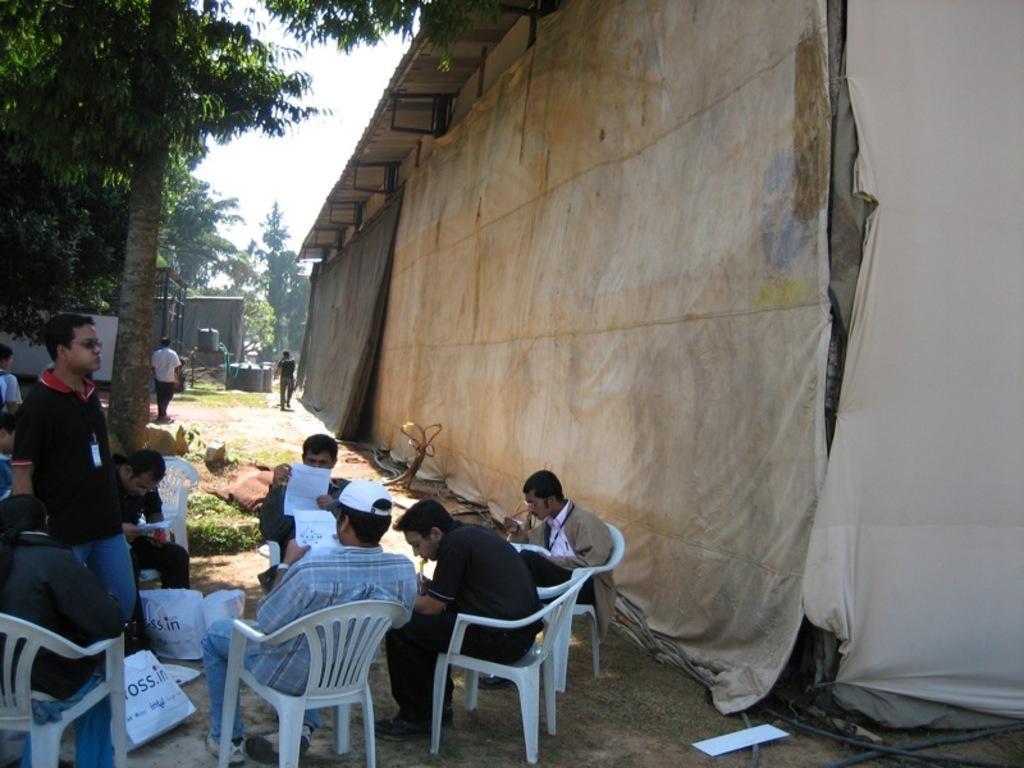In one or two sentences, can you explain what this image depicts? In the image in the center we can see some persons were sitting on the chair,and reading papers. And here we can see one man standing. And coming to the background we can see some persons were standing and trees and sky and sheet. 